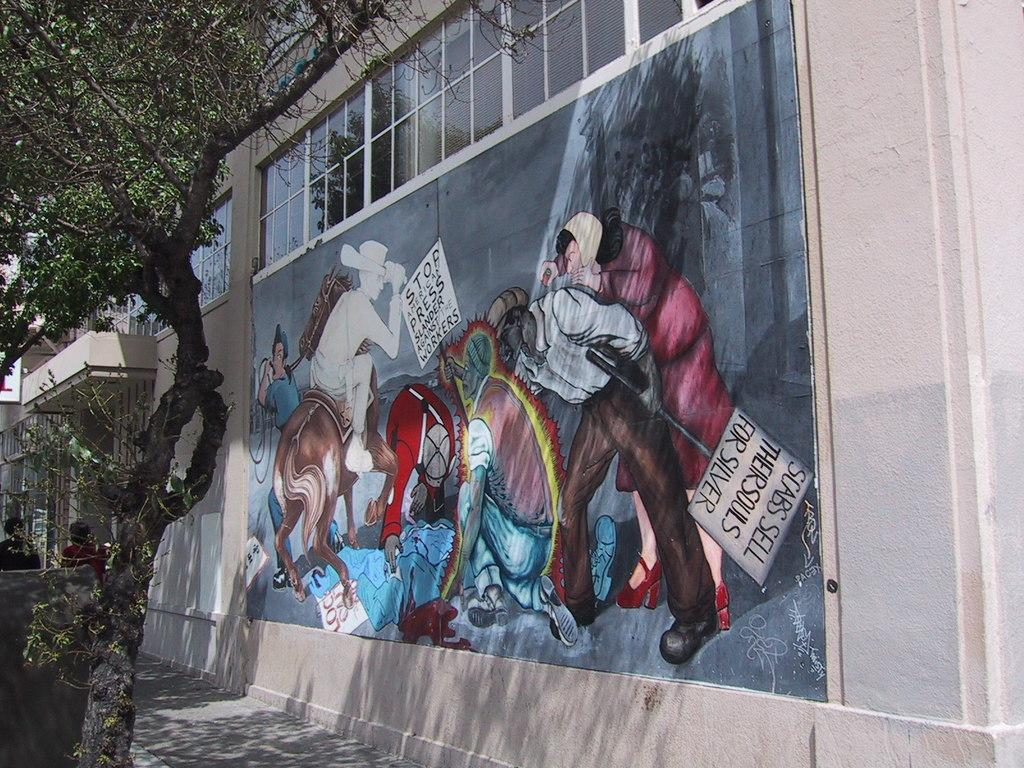What is located in the foreground of the image? There is a tree and a painting on the wall in the foreground of the image. Can you describe the tree in the image? The tree is located in the foreground of the image. What is depicted on the painting in the image? The painting on the wall in the foreground of the image is not described in the provided facts, so we cannot answer that question definitively. How many mice can be seen nesting in the tree in the image? There are no mice or nests visible in the image; it only features a tree and a painting on the wall. What type of guitar is leaning against the tree in the image? There is no guitar present in the image; it only features a tree and a painting on the wall. 